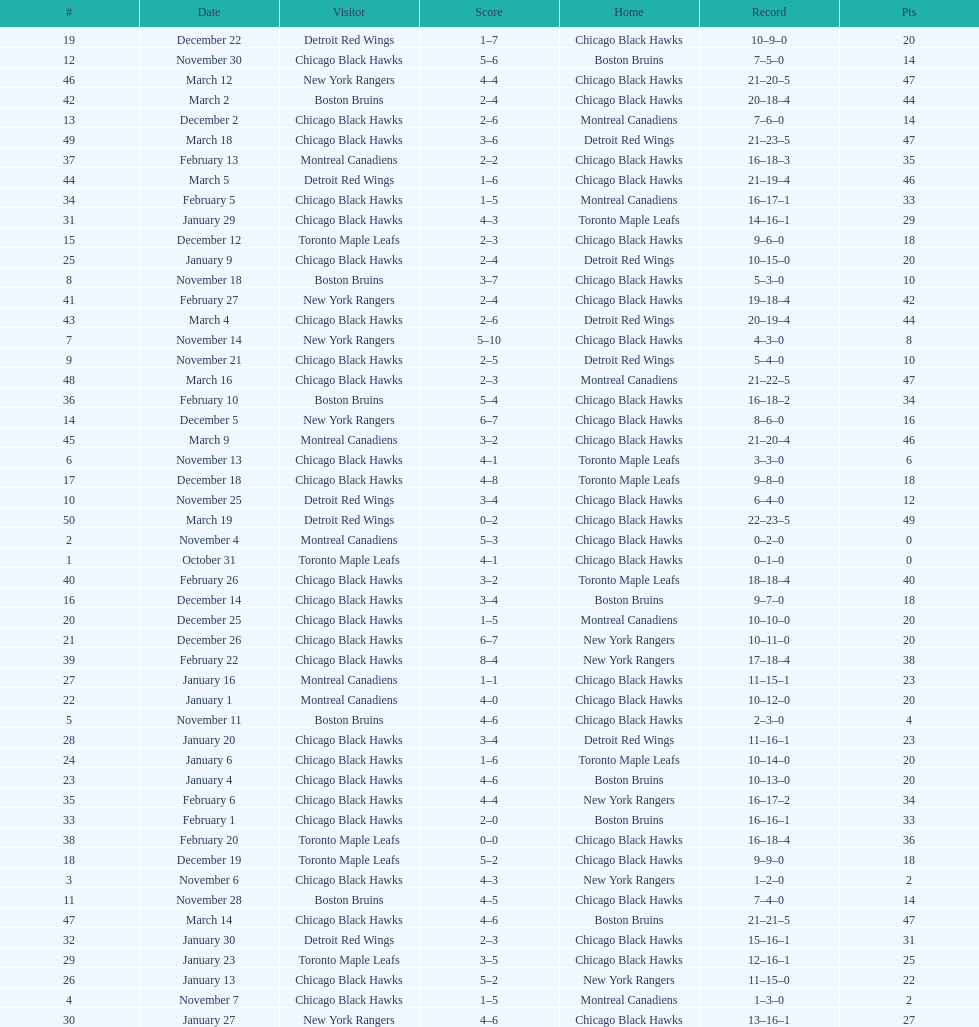How many games total were played? 50. 